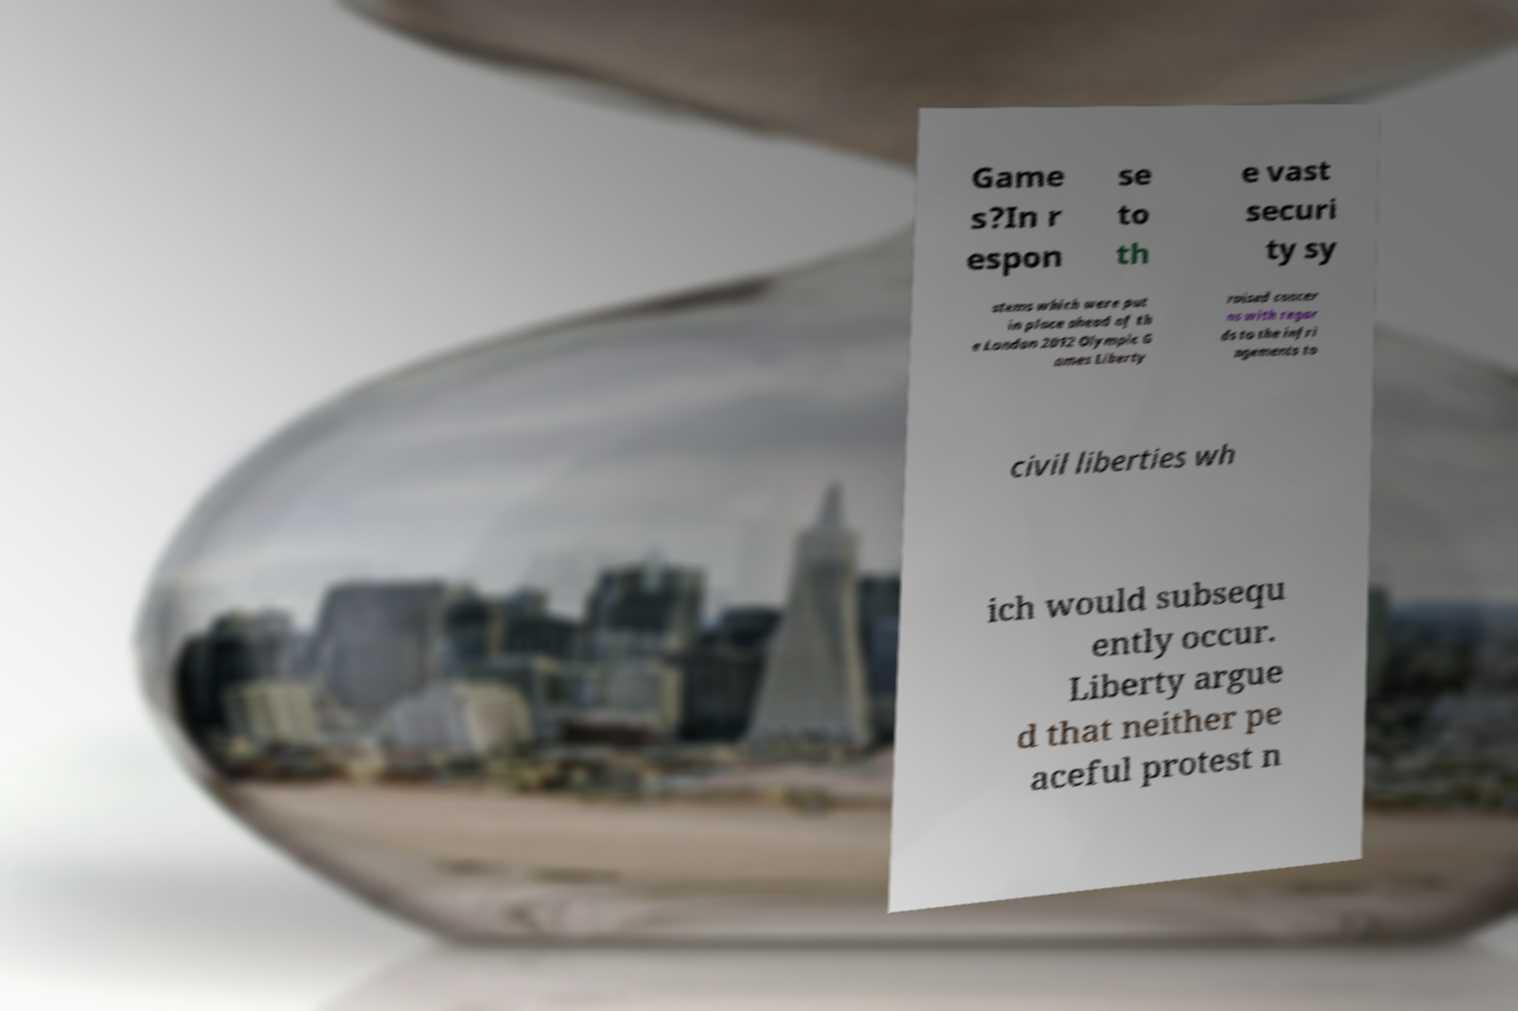For documentation purposes, I need the text within this image transcribed. Could you provide that? Game s?In r espon se to th e vast securi ty sy stems which were put in place ahead of th e London 2012 Olympic G ames Liberty raised concer ns with regar ds to the infri ngements to civil liberties wh ich would subsequ ently occur. Liberty argue d that neither pe aceful protest n 